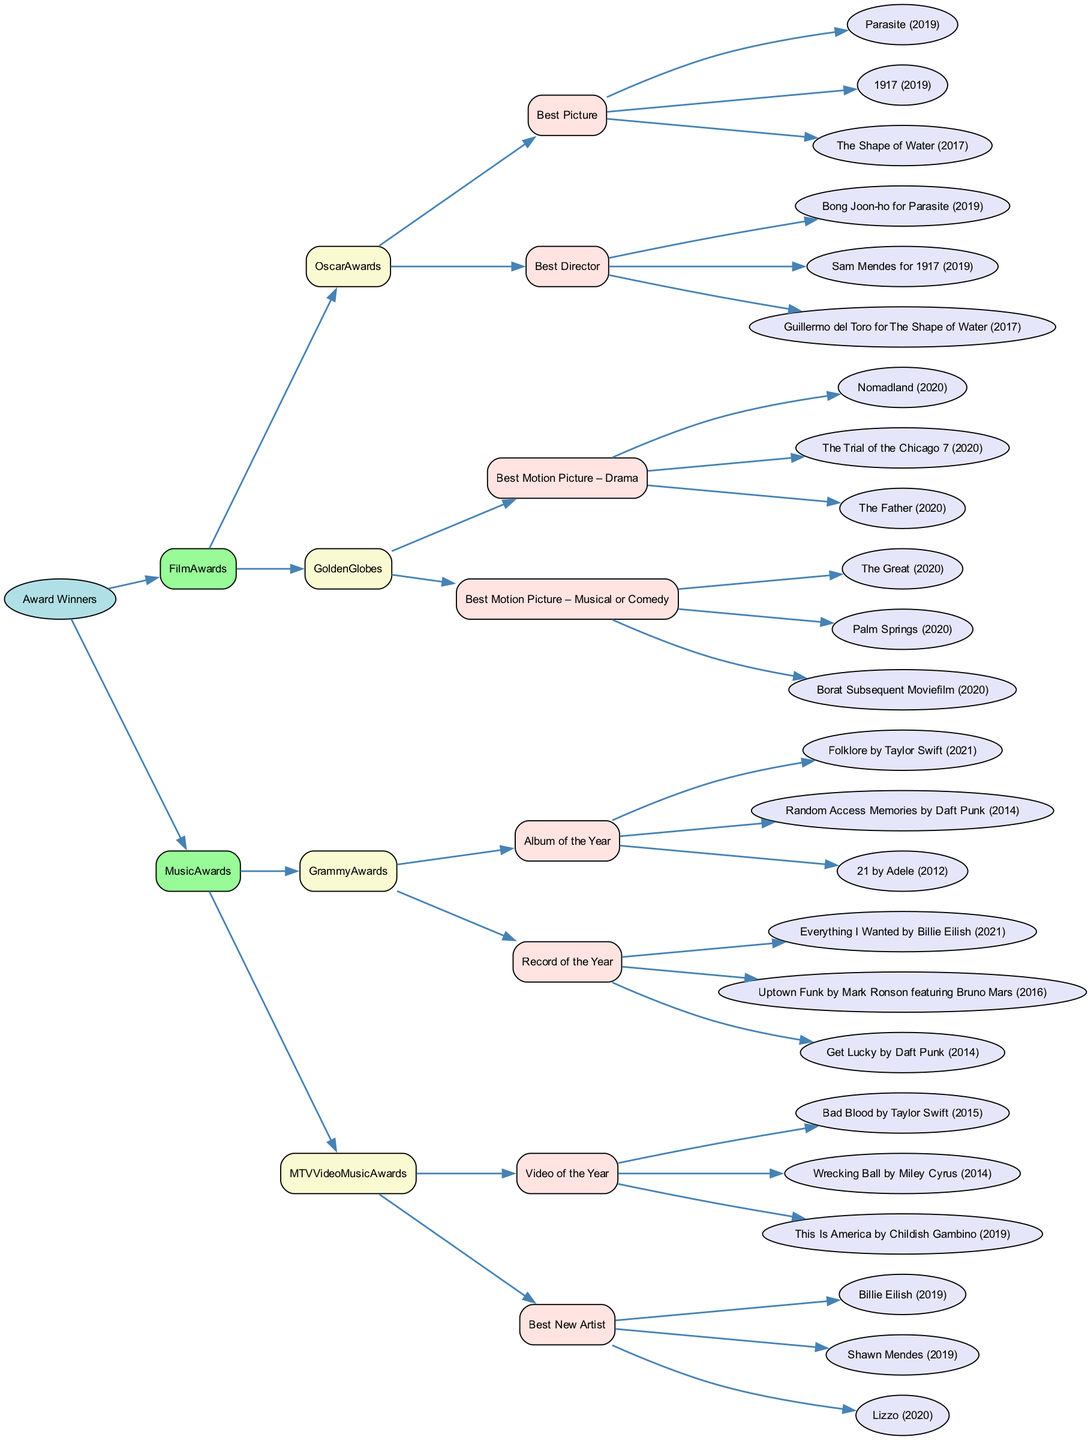What are the categories under Oscar Awards? The Oscar Awards has two main categories listed under it: Best Picture and Best Director. These are the only categories specified in the provided data.
Answer: Best Picture, Best Director How many nominations are there for Best Motion Picture – Drama at the Golden Globes? The Best Motion Picture – Drama category has three nominations listed: Nomadland, The Trial of the Chicago 7, and The Father. Therefore, the total count of nominations is three.
Answer: 3 Which film was nominated for Best Picture in 2019 at the Oscar Awards? In the nominations for Best Picture, Parasite was listed as a nominee in 2019. The question focuses on identifying a specific year and category.
Answer: Parasite (2019) Who directed The Shape of Water? The Shape of Water is directed by Guillermo del Toro. This can be deduced from the nominations under the Best Director category.
Answer: Guillermo del Toro How many music award categories are listed in the diagram? The diagram provides four music award categories: Album of the Year, Record of the Year, Video of the Year, and Best New Artist. By counting these categories across two awards, we arrive at a total of four.
Answer: 4 Which artist is nominated for Best New Artist at the MTV Video Music Awards? In the Best New Artist nominations, Billie Eilish is listed among other nominees, providing a direct answer to the question about one of the nominees in this category.
Answer: Billie Eilish What is the connection between the Grammy Awards and Taylor Swift? Taylor Swift is nominated for Album of the Year with her work Folklore in the Grammy Awards. This indicates that her work is part of a specific category under the Grammy Awards in the decision tree.
Answer: Folklore by Taylor Swift (2021) What is the total number of nominations for Video of the Year? The Video of the Year category lists three nominations: Bad Blood, Wrecking Ball, and This Is America. Therefore, when counting these nominations, the total is three.
Answer: 3 Which category does Random Access Memories belong to? Random Access Memories is nominated in the Album of the Year category at the Grammy Awards. This shows the specific relationship between the work and category in the decision tree.
Answer: Album of the Year 